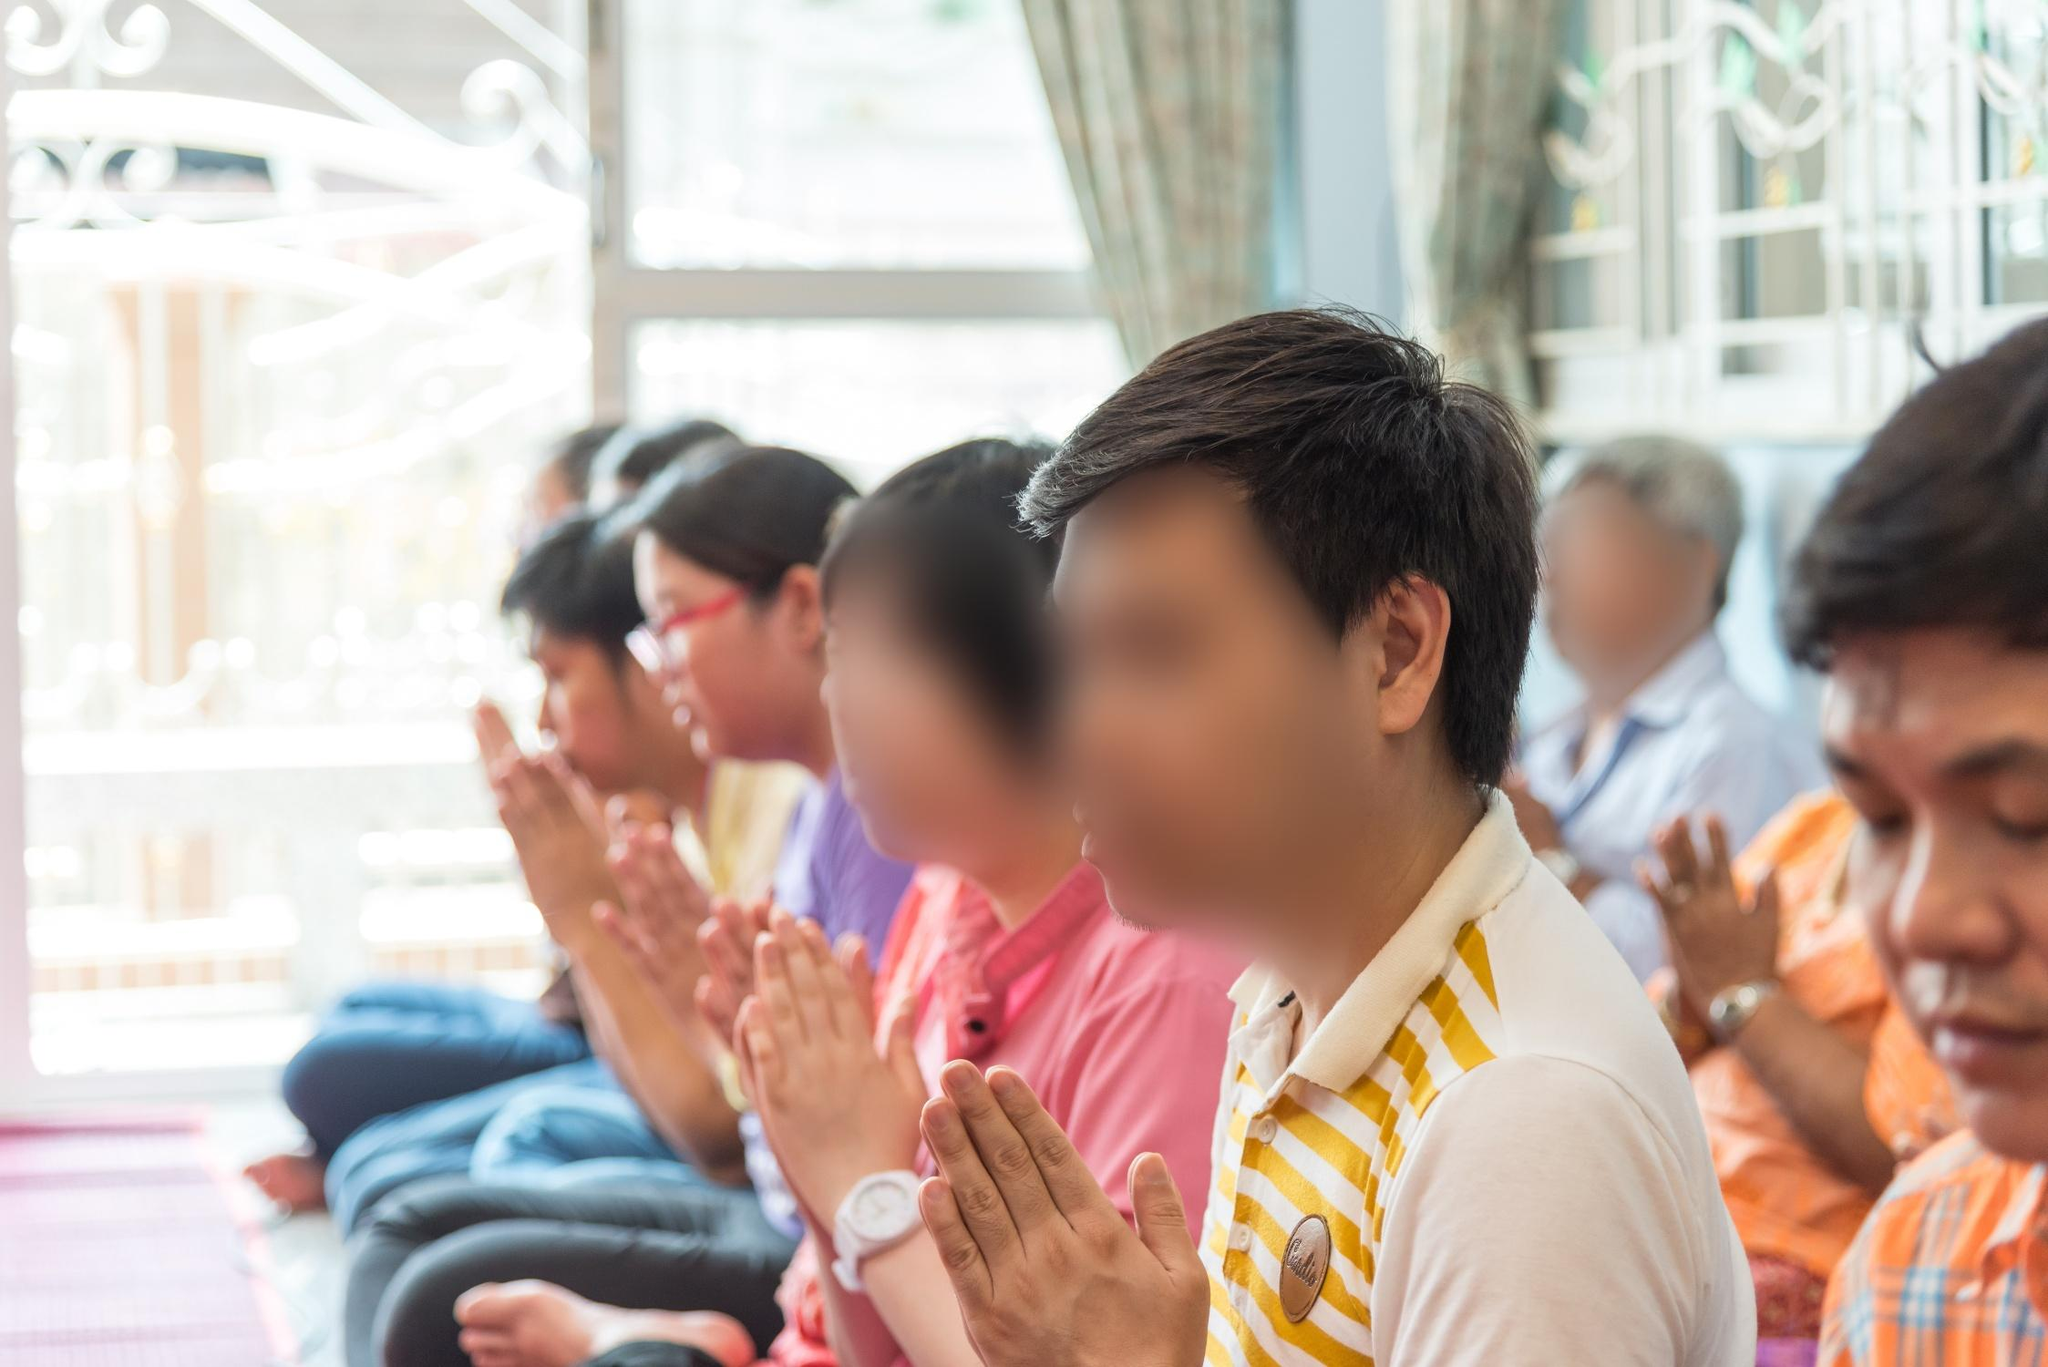Imagine you were there participating in the prayer. How would you feel? Participating in this prayer session, I would feel a profound sense of peace and belonging. The collective energy of unity and devotion would be humbling, grounding me in the present moment. The serene ambiance, marked by quiet murmurs of prayer and the soft glow of natural light, would evoke a deep sense of introspection. I would feel connected not only to the other individuals but also to a higher power, fostering a deep spiritual solace and tranquility. As the prayer session concludes, an elder in the group gently rises and moves towards a concealed niche in the temple wall, previously unnoticed by the participants. The niche, illuminated by a subtle, otherworldly glow, reveals an ancient relic—a beautifully ornate amulet, encrusted with precious stones and inscribed with sacred scriptures in an ancient language. The elder carefully retrieves the relic, sharing its mystical story with everyone: it is believed to be a divine gift, centuries old, entrusted to the temple by a celestial being, imbuing the bearer with wisdom and spiritual insight. The elder ceremoniously passes the amulet around, and as each individual touches it, a soft, warm light emanates, enveloping them, filling their hearts with divine knowledge and profound serenity. The relic's presence strengthens their faith, leaving an indelible mark on their spiritual journey, deepening their connection with the divine and each other. The narrative breathes life into the serene snapshot, transforming a moment of prayer into an epic tale of mystical discovery and collective enlightenment. 